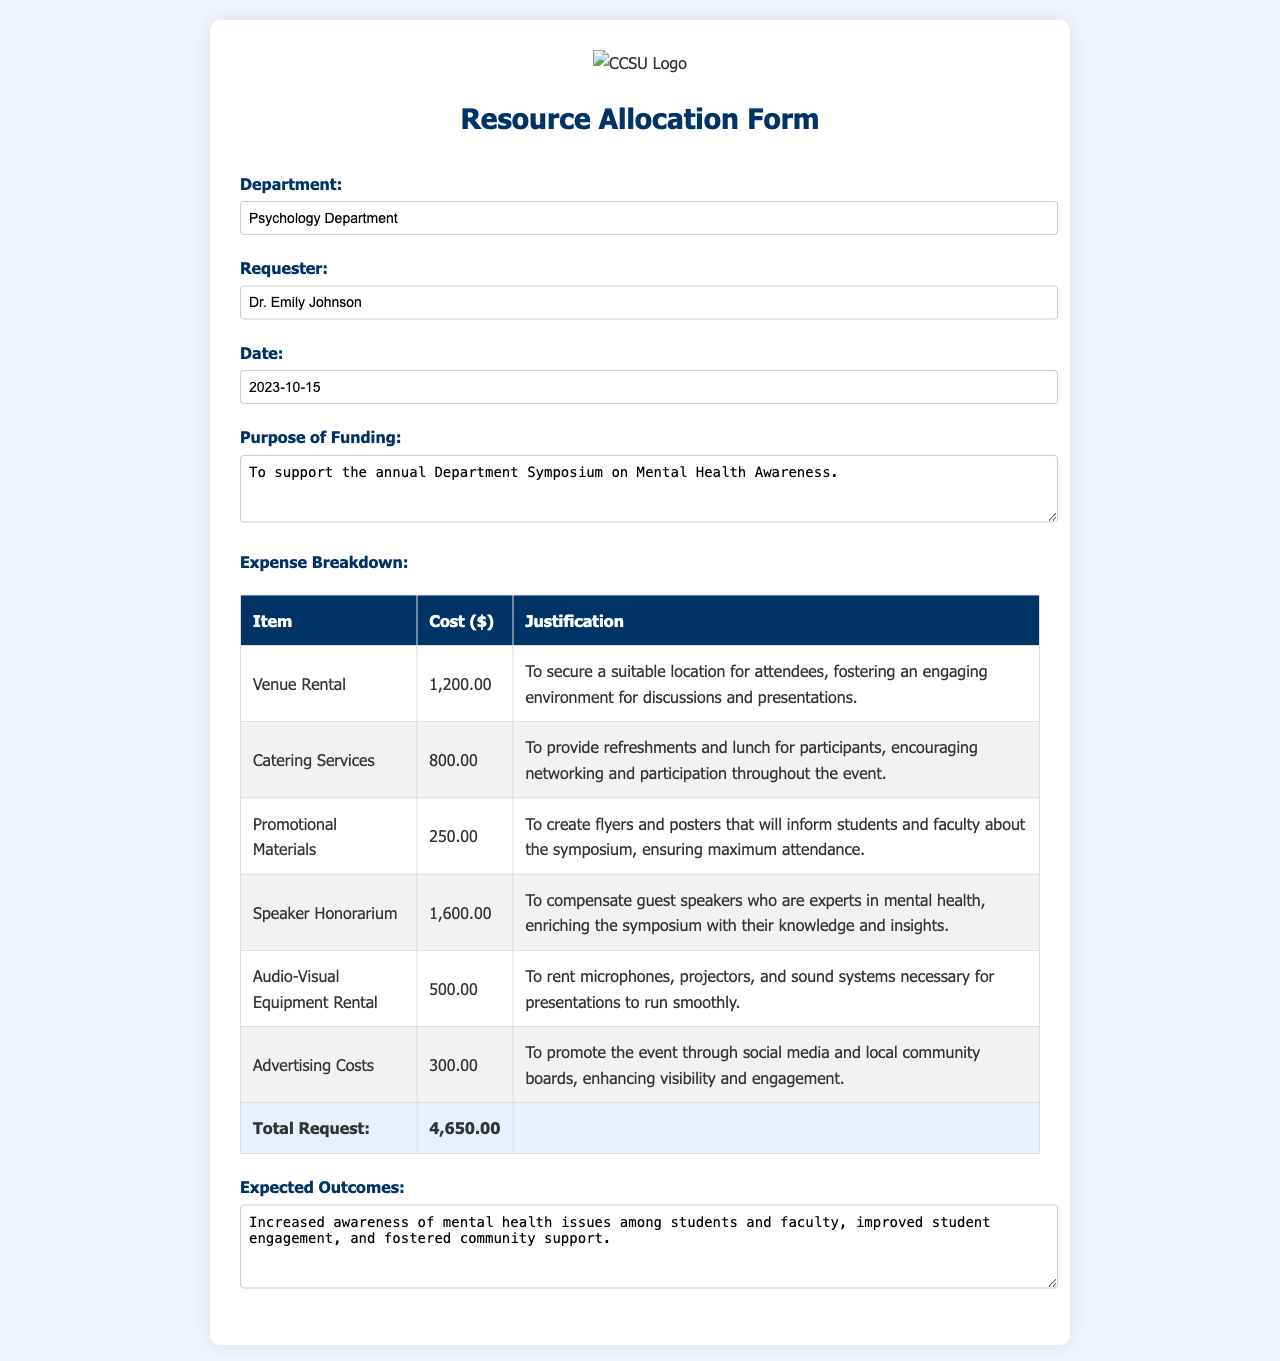What is the name of the requesting department? The requesting department is listed as the Psychology Department in the document.
Answer: Psychology Department Who is the requester of the funds? The requester of the funds is identified as Dr. Emily Johnson in the document.
Answer: Dr. Emily Johnson What is the total amount requested? The total amount requested is given at the end of the expense breakdown section, summing up the costs of all items.
Answer: 4,650.00 What is the date of the funding request? The date of the funding request is specified as 2023-10-15 in the document.
Answer: 2023-10-15 What is the purpose of the funding? The purpose of the funding is stated in the document, indicating the event it supports.
Answer: To support the annual Department Symposium on Mental Health Awareness How much is allocated for speaker honorarium? The allocated amount for speaker honorarium is found in the expense breakdown table specifically noted for that item.
Answer: 1,600.00 What are the expected outcomes stated in the form? The expected outcomes are mentioned as a summary in the document, highlighting the impact of the event.
Answer: Increased awareness of mental health issues among students and faculty, improved student engagement, and fostered community support What item has the highest cost in the expense breakdown? The item with the highest cost can be identified from the expense breakdown table by comparing all individual costs.
Answer: Speaker Honorarium How much is budgeted for advertising costs? The budgeted amount for advertising costs is detailed in the expense breakdown section of the document.
Answer: 300.00 